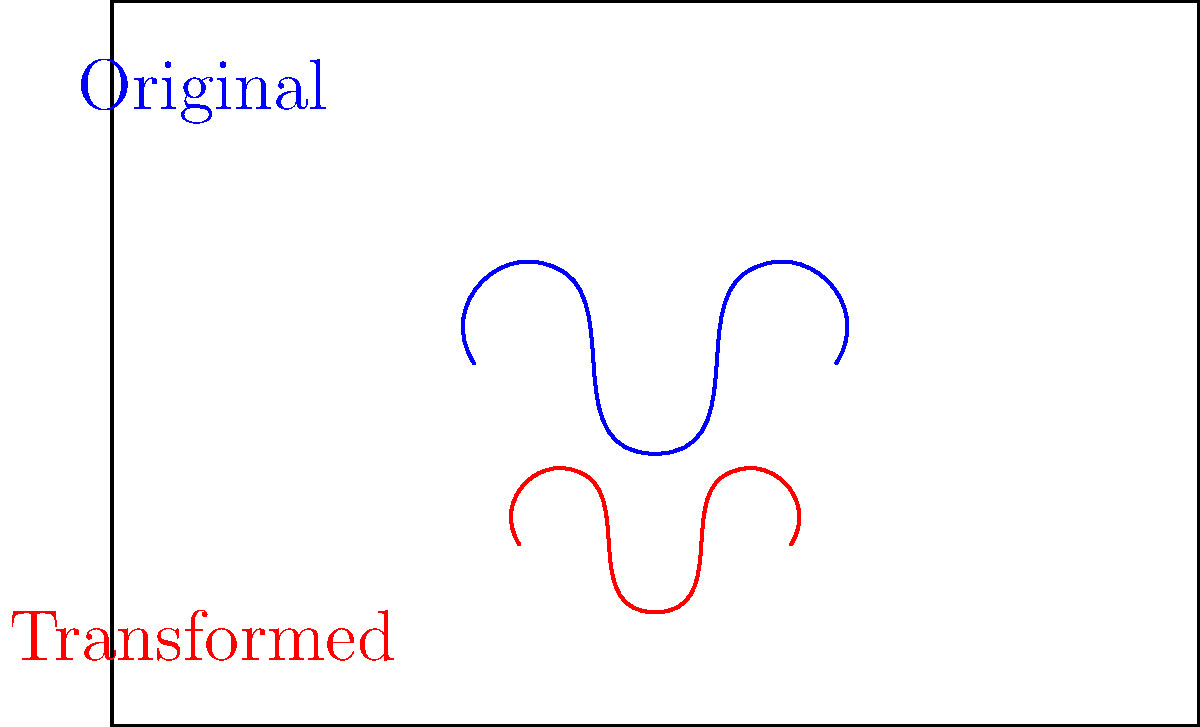You need to fit Kane Brown's signature within a rectangular album cover design. The original signature is represented by the blue curve, and the album cover dimensions are 6 units wide and 4 units tall. To fit the signature properly, you first translate it down by 1 unit and then scale it by a factor of 0.75. What is the resulting transformation matrix $T$ that combines these operations? Let's approach this step-by-step:

1) First, we need to recall the transformation matrices for translation and scaling:

   Translation matrix for $(0, -1)$: 
   $$T_1 = \begin{bmatrix} 1 & 0 & 0 \\ 0 & 1 & -1 \\ 0 & 0 & 1 \end{bmatrix}$$

   Scaling matrix for factor 0.75:
   $$T_2 = \begin{bmatrix} 0.75 & 0 & 0 \\ 0 & 0.75 & 0 \\ 0 & 0 & 1 \end{bmatrix}$$

2) To combine these transformations, we multiply the matrices in the order of application. We scale first, then translate, so we multiply $T_1$ by $T_2$:

   $$T = T_1 \cdot T_2 = \begin{bmatrix} 1 & 0 & 0 \\ 0 & 1 & -1 \\ 0 & 0 & 1 \end{bmatrix} \cdot \begin{bmatrix} 0.75 & 0 & 0 \\ 0 & 0.75 & 0 \\ 0 & 0 & 1 \end{bmatrix}$$

3) Multiplying these matrices:

   $$T = \begin{bmatrix} 0.75 & 0 & 0 \\ 0 & 0.75 & -1 \\ 0 & 0 & 1 \end{bmatrix}$$

This resulting matrix $T$ represents the combined transformation of scaling by 0.75 and then translating down by 1 unit.
Answer: $$T = \begin{bmatrix} 0.75 & 0 & 0 \\ 0 & 0.75 & -1 \\ 0 & 0 & 1 \end{bmatrix}$$ 